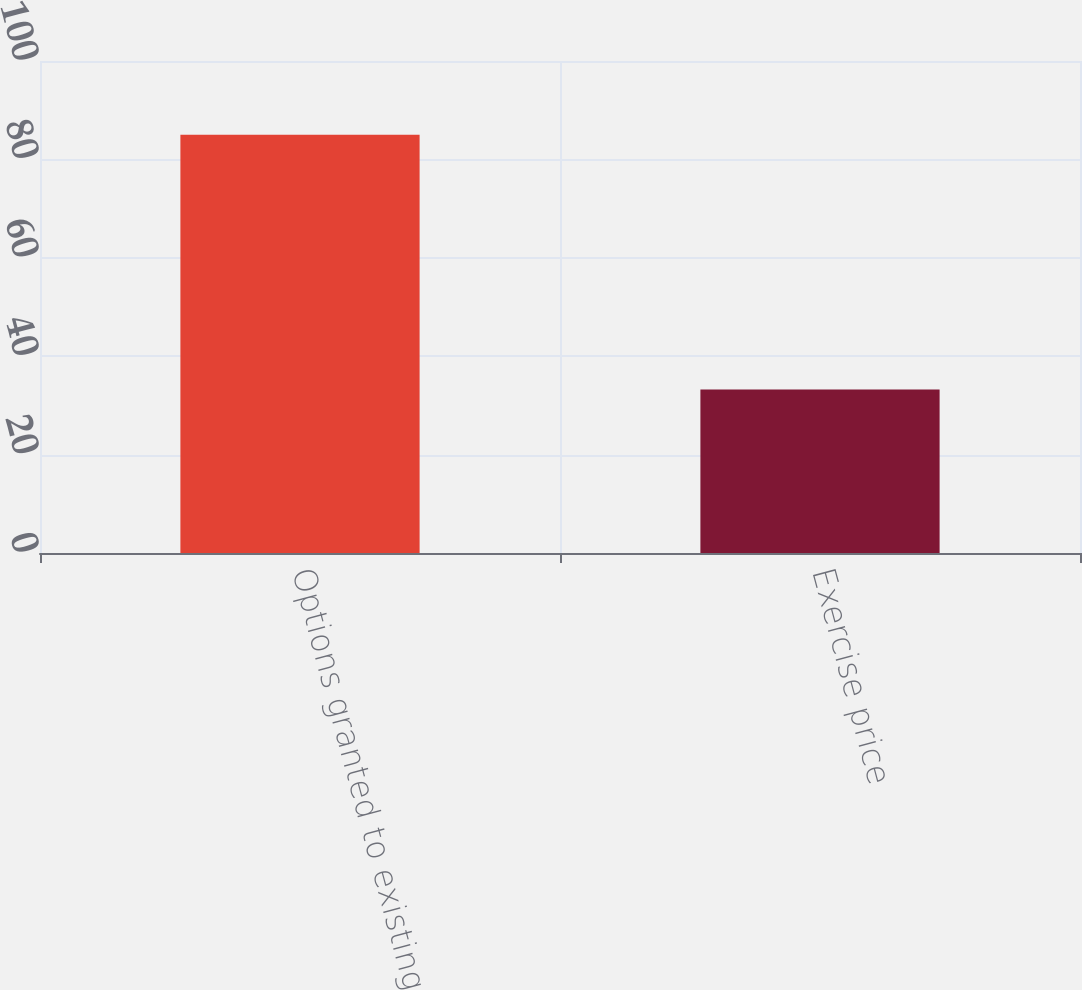Convert chart to OTSL. <chart><loc_0><loc_0><loc_500><loc_500><bar_chart><fcel>Options granted to existing<fcel>Exercise price<nl><fcel>85<fcel>33.23<nl></chart> 